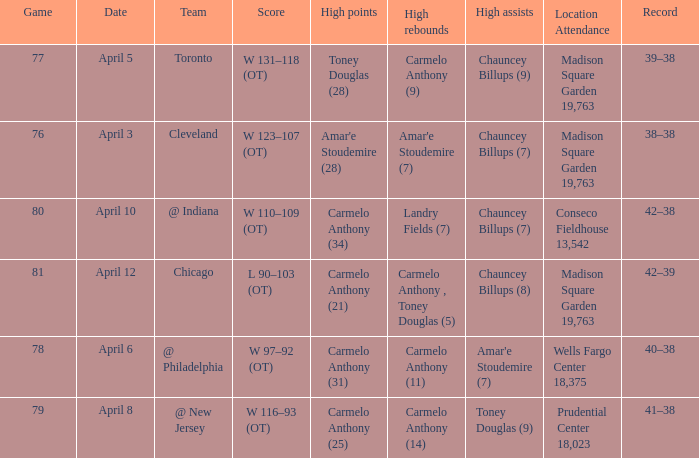Name the high assists for madison square garden 19,763 and record is 39–38 Chauncey Billups (9). 